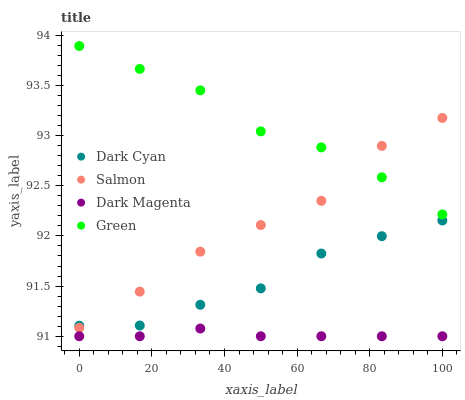Does Dark Magenta have the minimum area under the curve?
Answer yes or no. Yes. Does Green have the maximum area under the curve?
Answer yes or no. Yes. Does Salmon have the minimum area under the curve?
Answer yes or no. No. Does Salmon have the maximum area under the curve?
Answer yes or no. No. Is Dark Magenta the smoothest?
Answer yes or no. Yes. Is Salmon the roughest?
Answer yes or no. Yes. Is Green the smoothest?
Answer yes or no. No. Is Green the roughest?
Answer yes or no. No. Does Dark Magenta have the lowest value?
Answer yes or no. Yes. Does Salmon have the lowest value?
Answer yes or no. No. Does Green have the highest value?
Answer yes or no. Yes. Does Salmon have the highest value?
Answer yes or no. No. Is Dark Magenta less than Salmon?
Answer yes or no. Yes. Is Dark Cyan greater than Dark Magenta?
Answer yes or no. Yes. Does Salmon intersect Dark Cyan?
Answer yes or no. Yes. Is Salmon less than Dark Cyan?
Answer yes or no. No. Is Salmon greater than Dark Cyan?
Answer yes or no. No. Does Dark Magenta intersect Salmon?
Answer yes or no. No. 